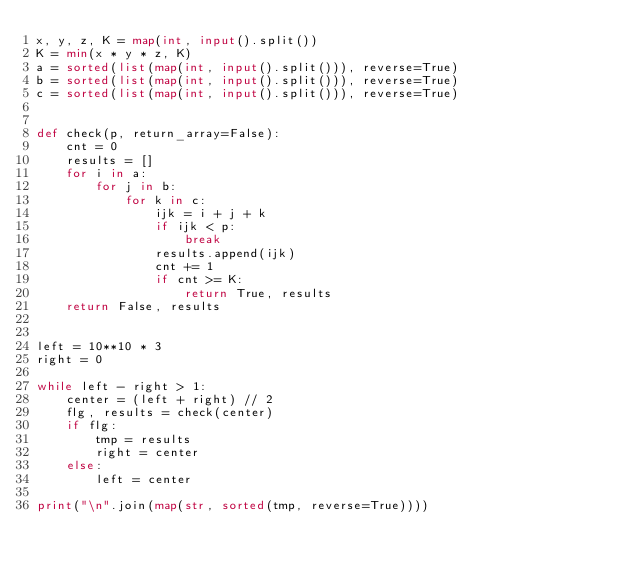<code> <loc_0><loc_0><loc_500><loc_500><_Python_>x, y, z, K = map(int, input().split())
K = min(x * y * z, K)
a = sorted(list(map(int, input().split())), reverse=True)
b = sorted(list(map(int, input().split())), reverse=True)
c = sorted(list(map(int, input().split())), reverse=True)


def check(p, return_array=False):
    cnt = 0
    results = []
    for i in a:
        for j in b:
            for k in c:
                ijk = i + j + k
                if ijk < p:
                    break
                results.append(ijk)
                cnt += 1
                if cnt >= K:
                    return True, results
    return False, results


left = 10**10 * 3
right = 0

while left - right > 1:
    center = (left + right) // 2
    flg, results = check(center)
    if flg:
        tmp = results
        right = center
    else:
        left = center

print("\n".join(map(str, sorted(tmp, reverse=True))))
</code> 